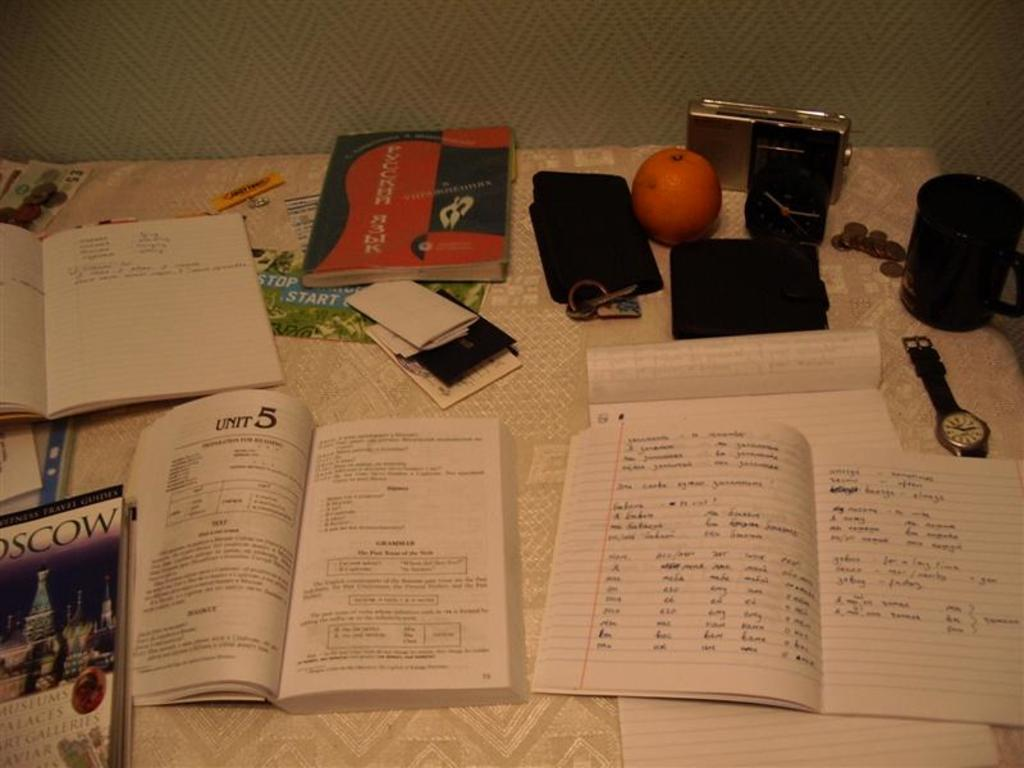<image>
Give a short and clear explanation of the subsequent image. open books with one to a page that says 'unit 5' at the top of it 